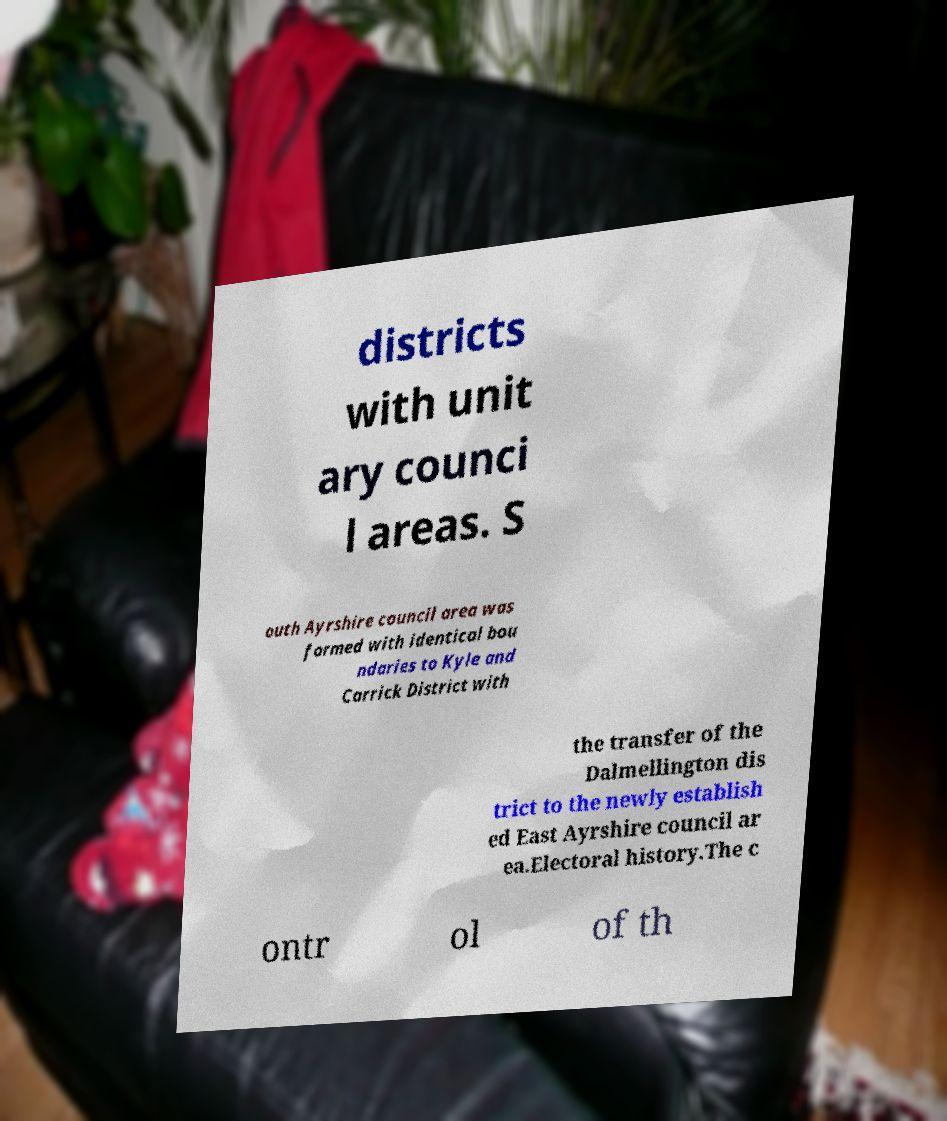I need the written content from this picture converted into text. Can you do that? districts with unit ary counci l areas. S outh Ayrshire council area was formed with identical bou ndaries to Kyle and Carrick District with the transfer of the Dalmellington dis trict to the newly establish ed East Ayrshire council ar ea.Electoral history.The c ontr ol of th 